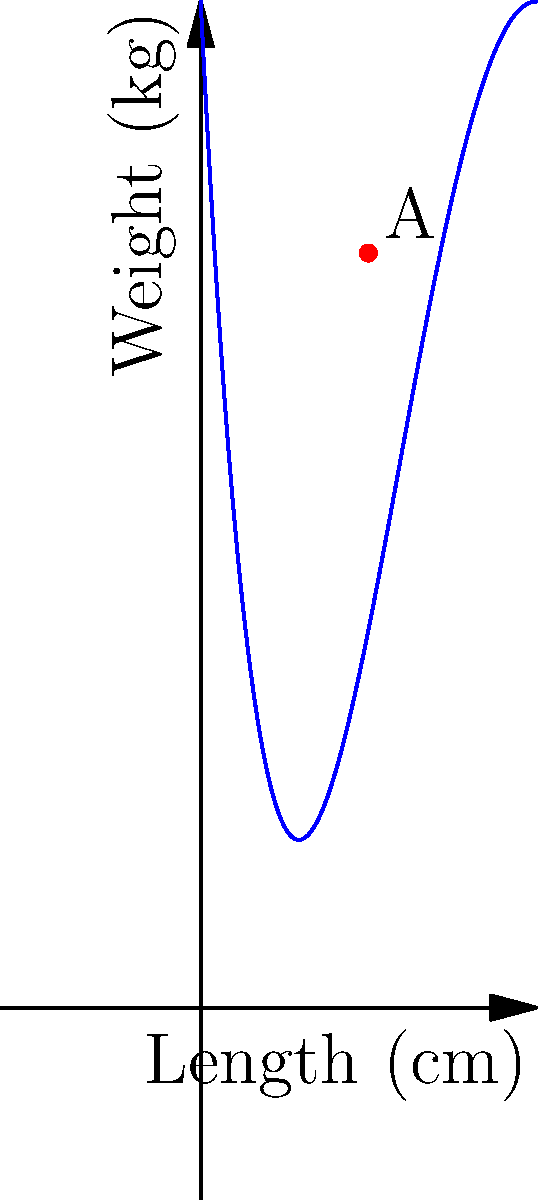The weight distribution of a fighting robot can be modeled by the quartic function $W(x) = 0.01x^4 - 0.4x^3 + 5x^2 - 20x + 30$, where $W$ is the weight in kg and $x$ is the distance from the front in cm. Point A (5, 22.5) represents the robot's center of gravity. What is the rate of change of the robot's weight distribution at its center of gravity? To find the rate of change of the robot's weight distribution at its center of gravity, we need to calculate the derivative of the weight function $W(x)$ and evaluate it at $x = 5$.

Step 1: Find the derivative of $W(x)$.
$W'(x) = \frac{d}{dx}(0.01x^4 - 0.4x^3 + 5x^2 - 20x + 30)$
$W'(x) = 0.04x^3 - 1.2x^2 + 10x - 20$

Step 2: Evaluate $W'(x)$ at $x = 5$ (the center of gravity).
$W'(5) = 0.04(5^3) - 1.2(5^2) + 10(5) - 20$
$W'(5) = 0.04(125) - 1.2(25) + 50 - 20$
$W'(5) = 5 - 30 + 50 - 20$
$W'(5) = 5$

Therefore, the rate of change of the robot's weight distribution at its center of gravity is 5 kg/cm.
Answer: 5 kg/cm 